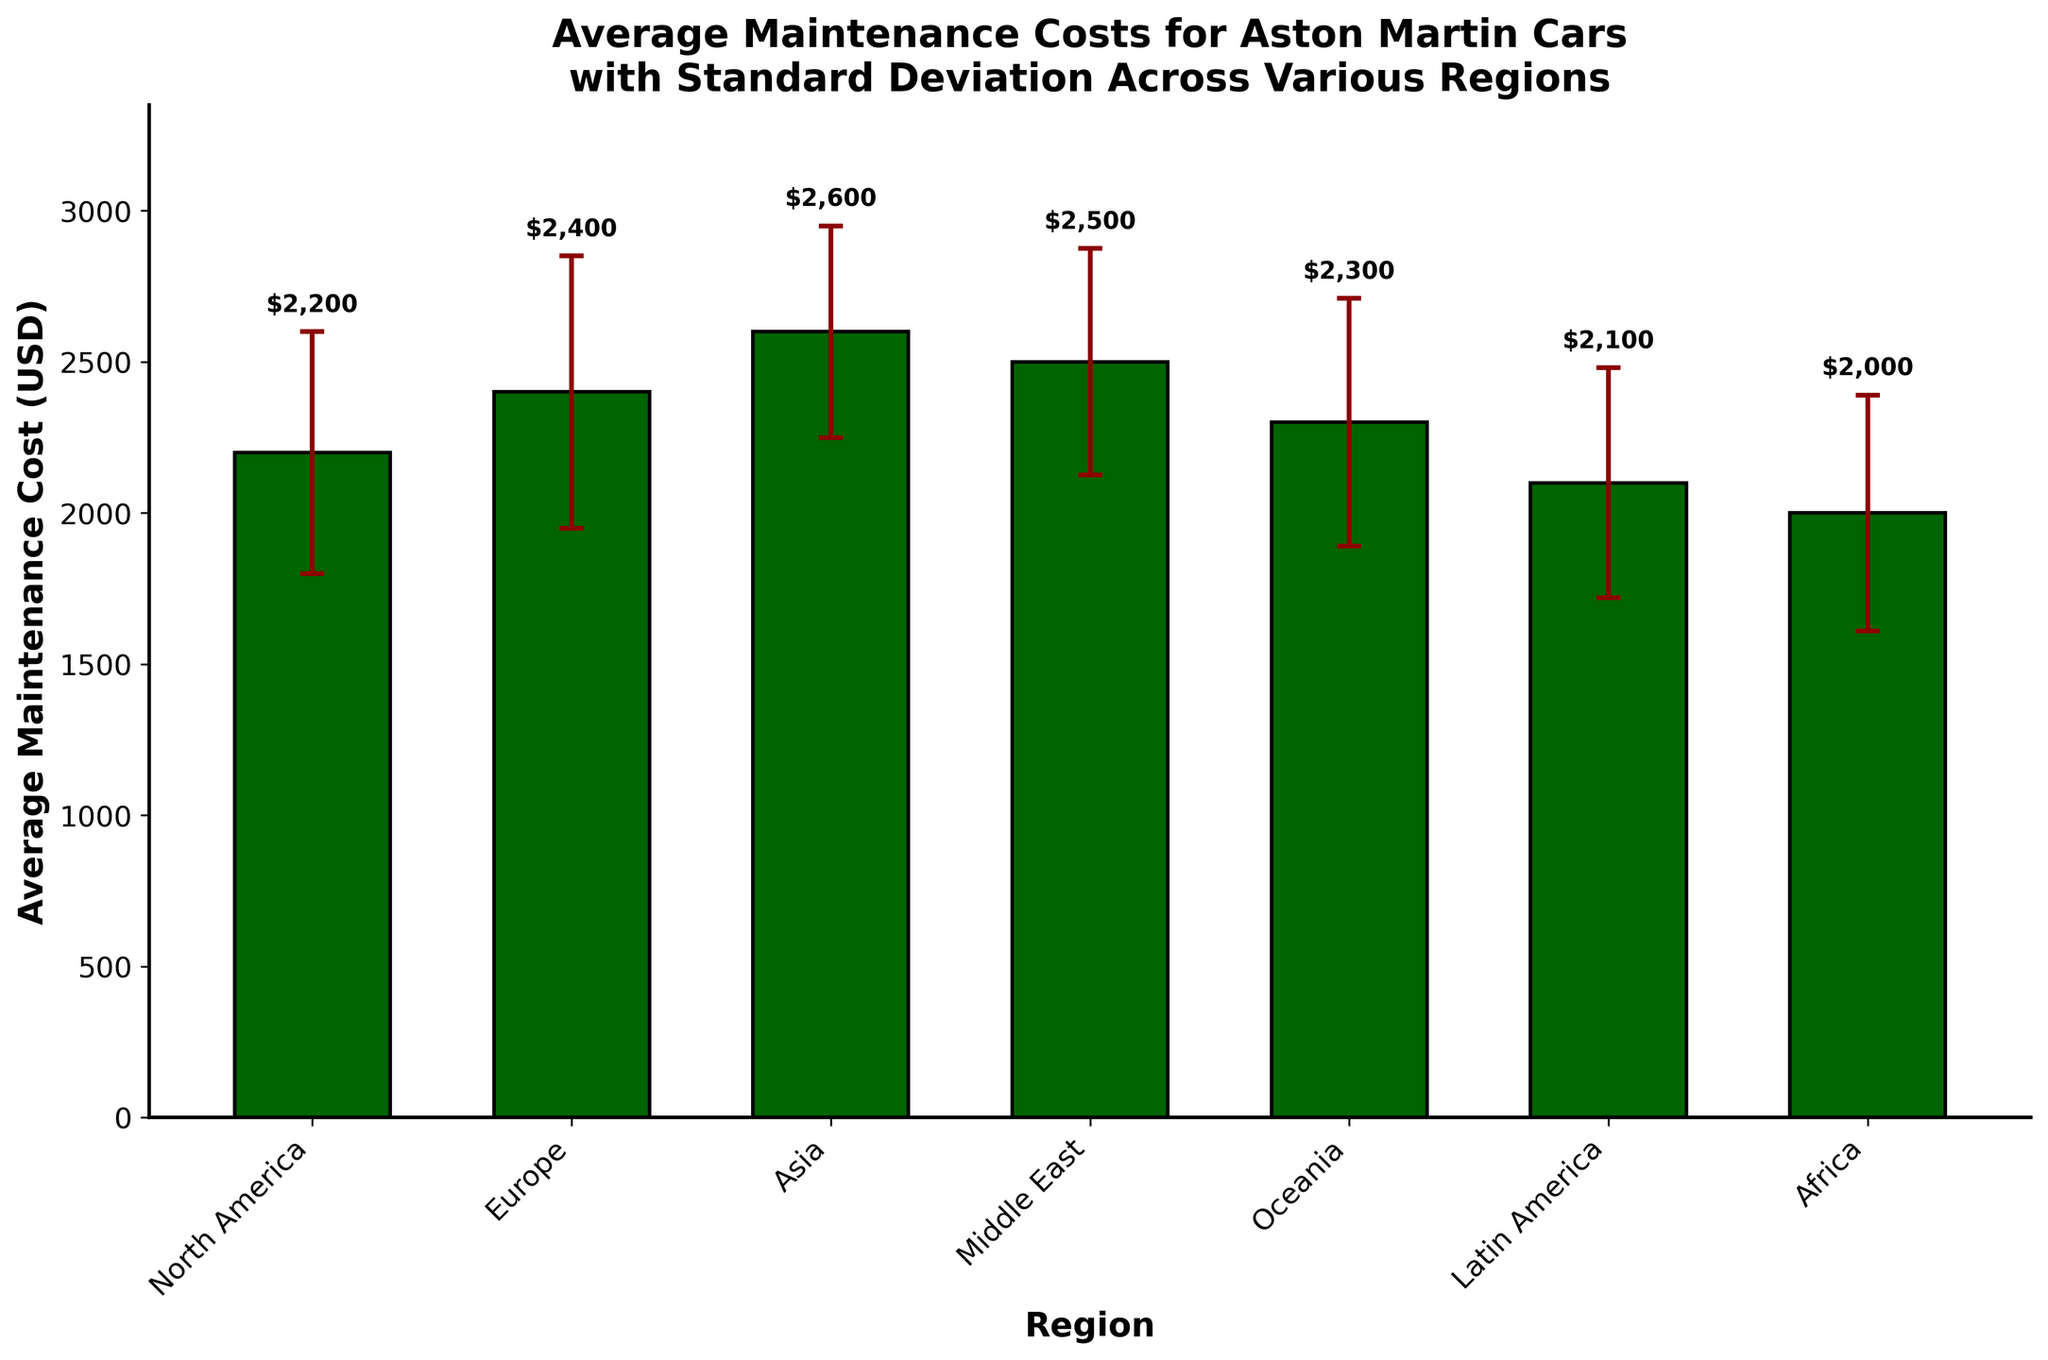what is the average maintenance cost in Europe? The average maintenance cost in Europe is directly provided in the graph's data, looking at the bar labeled "Europe."
Answer: 2400 USD What region has the highest average maintenance cost for Aston Martin cars? By comparing the heights of all the bars visually, the region with the highest bar corresponds to the highest average maintenance cost.
Answer: Asia How much higher is the average maintenance cost in North America compared to Africa? Find the heights of the bars for both North America and Africa. Subtract the maintenance cost in Africa from the maintenance cost in North America.
Answer: 2200 - 2000 = 200 USD Which two regions have the closest average maintenance costs? By observing the bar heights, visually assess which two bars are closest in height. Comparing all pairs, the Middle East and Oceania bars seem closest. Checking their values: Middle East (2500 USD) and Oceania (2300 USD) => 2500 - 2300 = 200 USD.
Answer: Oceania and North America What is the combined average maintenance cost for Europe and Latin America? Add the average maintenance costs for Europe (2400 USD) and Latin America (2100 USD) directly.
Answer: 2400 + 2100 = 4500 USD In which regions does the average maintenance cost fall within one standard deviation of 2500 USD? Identify the bars where the sum of the average maintenance cost and standard deviation, along with the difference, falls within the range of 2500 ± the standard deviation. This includes 2500 itself.
Answer: Europe (2400 ± 450 = 1950 - 2850), Middle East (2500 ± 375 = 2125 - 2875), Oceania (2300 ± 410 = 1890 - 2710), Latin America (2100 ± 380 = 1720 - 2480) What is the apparent trend in average maintenance costs from lower-maintenance regions to higher-maintenance regions? The bar chart shows an increasing trend from left to right, starting with Africa at 2000 USD and increasing towards Asia at 2600 USD. This indicates that average maintenance costs generally increase across regions, with variations due to standard deviations visible through the error bars.
Answer: Increasing trend from Africa to Asia 